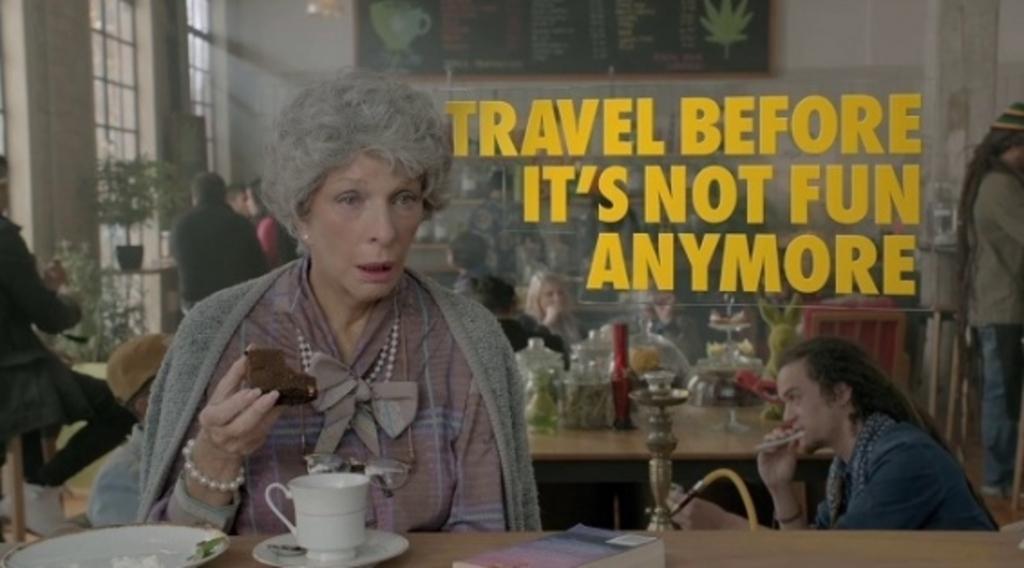How would you summarize this image in a sentence or two? There is a lady holding a piece of cake. She is wearing chains and a bracelet. In front of her there is a table with plate, cup, saucer and book. In the back there are many people. There is a hookah. Also there is a table with crystal vessels and many other items. In the back there is a wall with board. Also there are windows and a pot with plants. Also something is written on the image. 